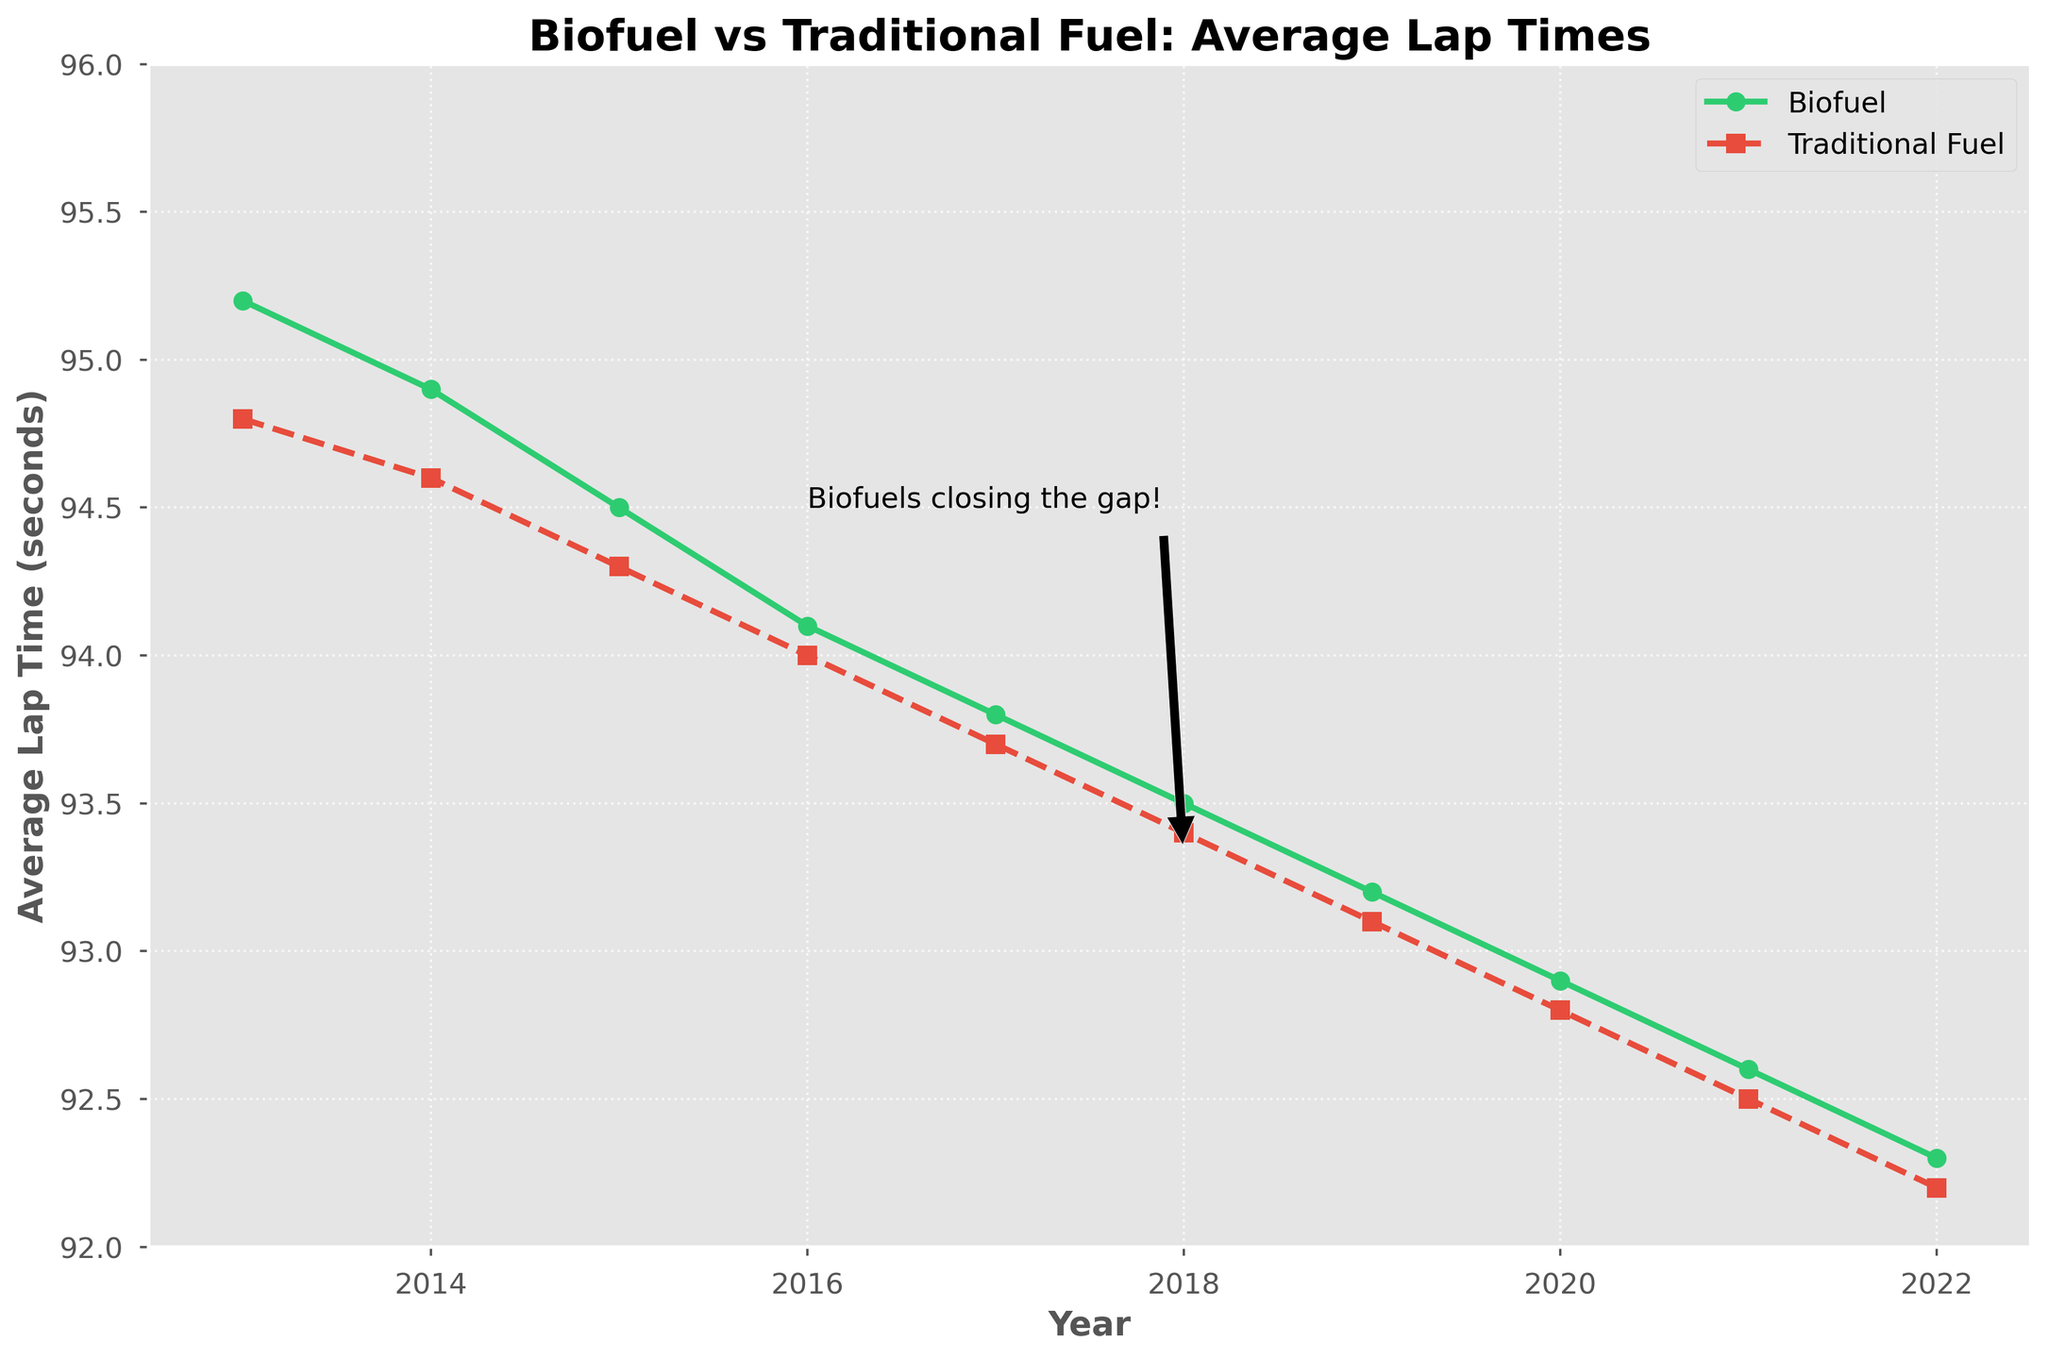What is the general trend from 2013 to 2022 for biofuel average lap times? The biofuel average lap time has consistently decreased from 95.2 seconds in 2013 to 92.3 seconds in 2022, indicating an improvement in performance over the years.
Answer: Decreasing How do the traditional fuel average lap times compare to biofuel average lap times in 2020? In 2020, the traditional fuel average lap time is 92.8 seconds, while the biofuel average lap time is 92.9 seconds, so the traditional fuel lap time is slightly lower.
Answer: Traditional fuel is slightly lower Between which years did the biofuel-powered race cars see the most noticeable improvement in average lap times? The steepest decline in biofuel average lap times appears between 2017 and 2018, from 93.8 to 93.5 seconds.
Answer: 2017 to 2018 By how many seconds did the biofuel average lap time improve from 2013 to 2022? The biofuel average lap time improved from 95.2 seconds in 2013 to 92.3 seconds in 2022, a difference of 2.9 seconds.
Answer: 2.9 seconds In which year did the traditional fuel and biofuel average lap times first become closest? In 2016, the biofuel average lap time was 94.1 seconds, and the traditional fuel average lap time was 94.0 seconds, making them closest in this year.
Answer: 2016 What does the annotation "Biofuels closing the gap!" in the plot refer to? The annotation at 2018 with text "Biofuels closing the gap!" refers to the noticeable reduction in the gap between average lap times of biofuel and traditional fuel-powered cars, indicating that biofuels are becoming more competitive.
Answer: Reduction in gap by 2018 What is the difference in average lap times between biofuel and traditional fuel in 2019? In 2019, the biofuel average lap time is 93.2 seconds and the traditional fuel average lap time is 93.1 seconds, so the difference is 0.1 seconds.
Answer: 0.1 seconds Looking at the overall decline of average lap times between biofuel and traditional fuel, which category shows a larger improvement over the decade? Biofuel average lap time improved from 95.2 seconds in 2013 to 92.3 seconds in 2022, a 2.9-second improvement. Traditional fuel improved from 94.8 seconds in 2013 to 92.2 seconds in 2022, a 2.6-second improvement. Thus, biofuels show a larger improvement.
Answer: Biofuels What is the visual difference between the lines representing biofuels and traditional fuels? The biofuel line is denoted by green color with circular markers and a solid line, while the traditional fuel line is red with square markers and a dashed line.
Answer: Green circles, solid line for Biofuel; Red squares, dashed line for Traditional Fuel 